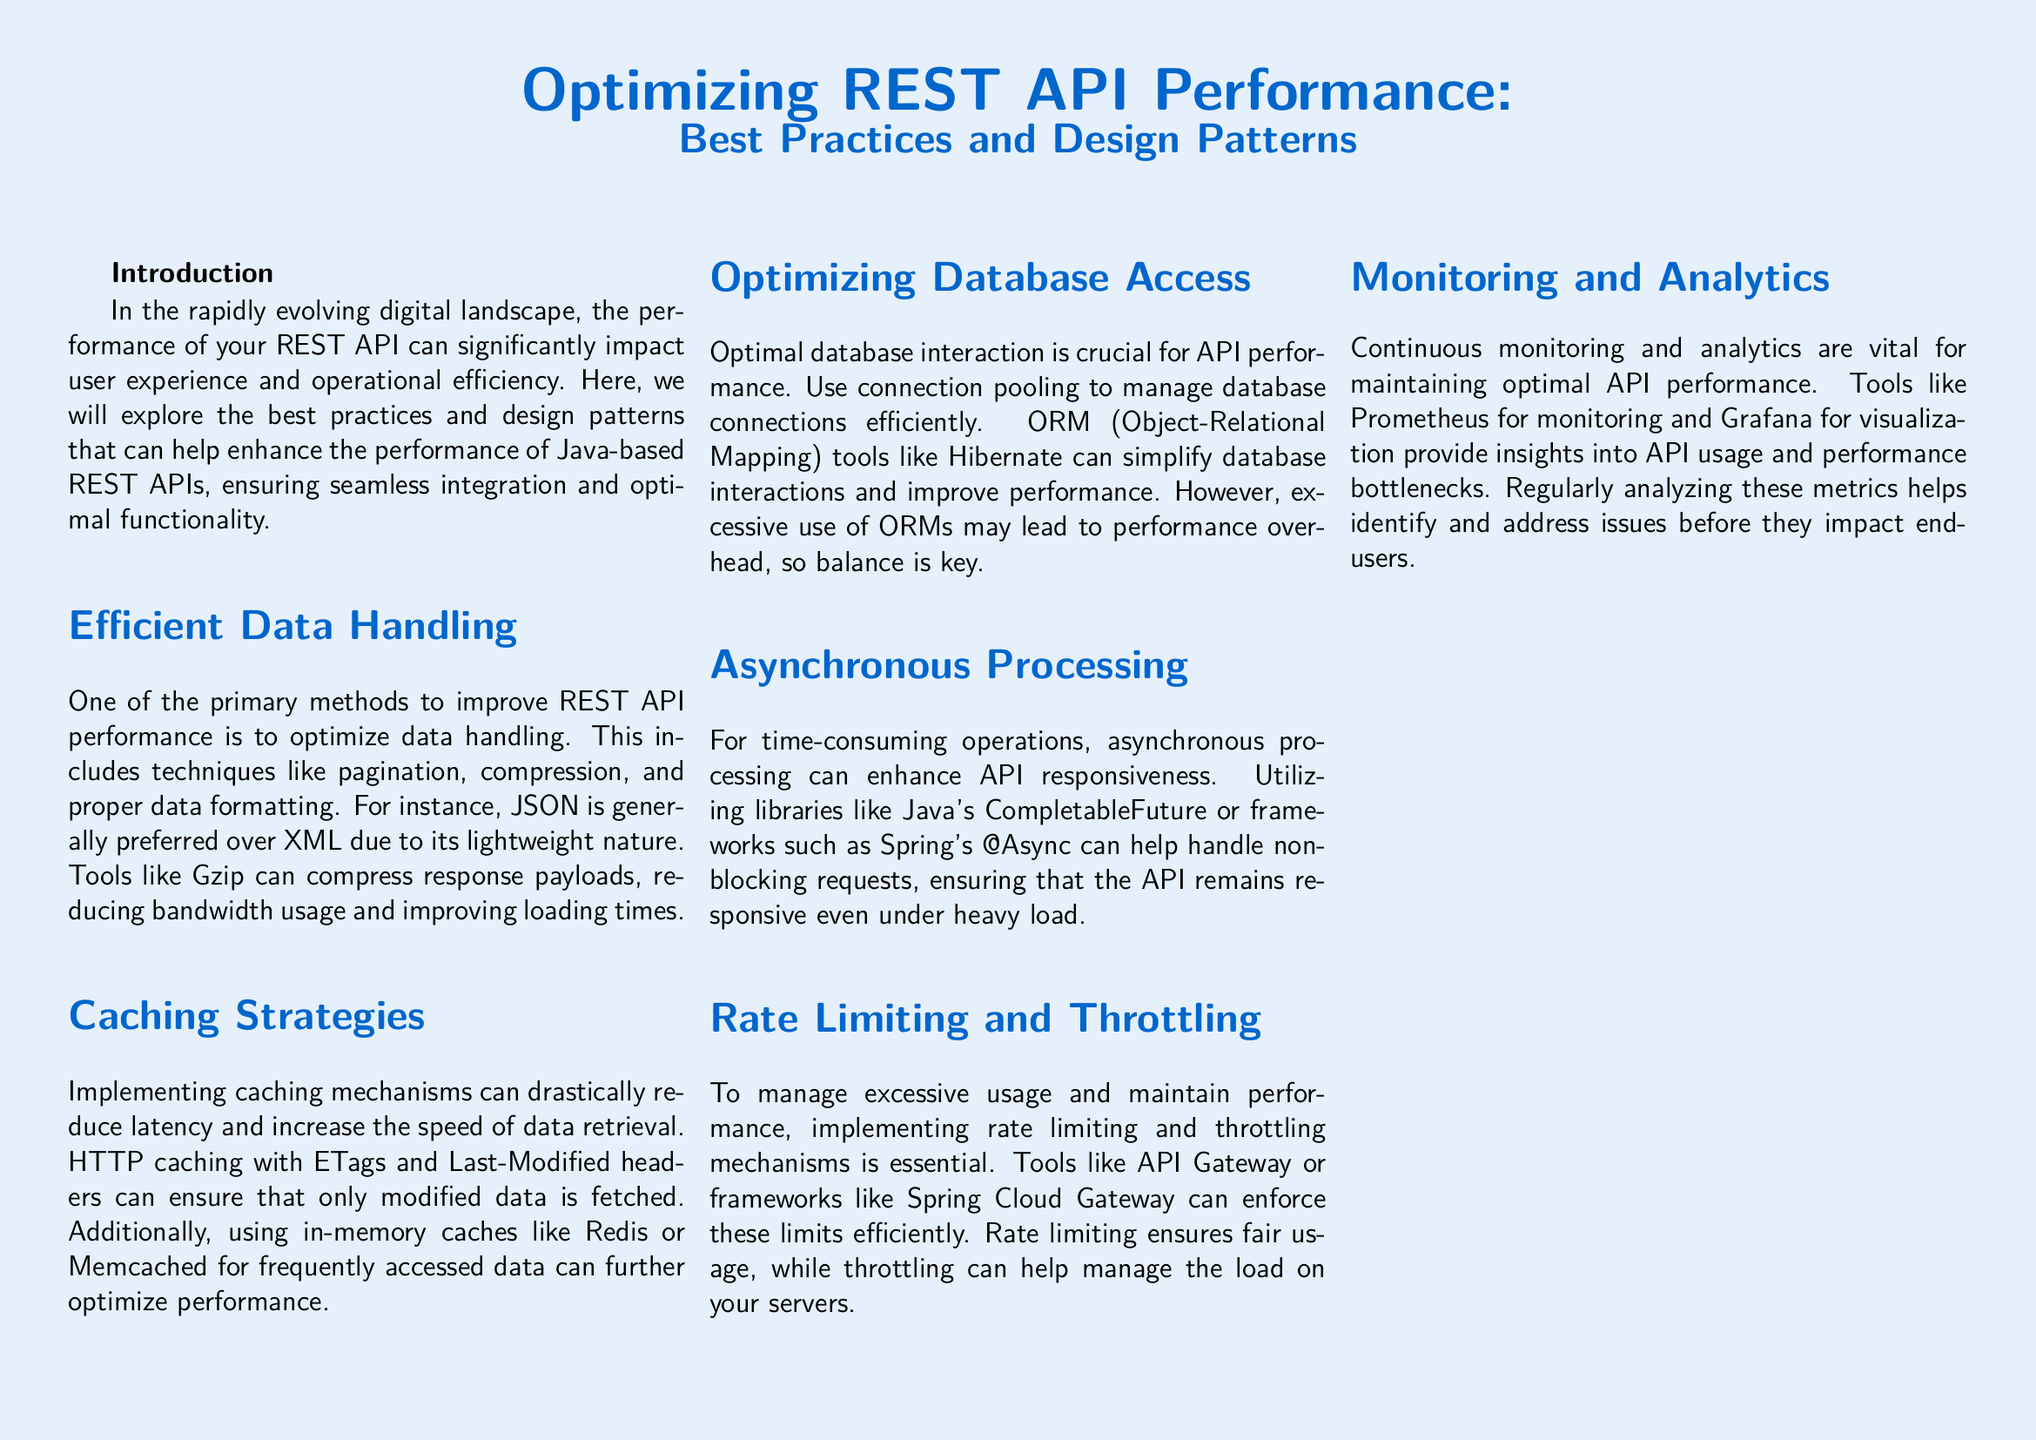What is the main topic of the whitepaper? The main topic of the whitepaper is about improving performance in REST APIs, particularly for Java-based systems.
Answer: Optimizing REST API Performance What should be preferred for data formatting in REST APIs? JSON is preferred because of its lightweight nature compared to XML.
Answer: JSON Which caching tools are mentioned in the document? The document mentions in-memory caches like Redis and Memcached for optimizing performance.
Answer: Redis, Memcached What is a critical method for enhancing API responsiveness for time-consuming operations? Asynchronous processing is highlighted as a necessary enhancement for API responsiveness.
Answer: Asynchronous processing Which monitoring tools are suggested for maintaining optimal API performance? The document suggests using Prometheus for monitoring and Grafana for visualization of API performance.
Answer: Prometheus, Grafana What is a key benefit of implementing rate limiting? Rate limiting ensures fair usage of the API among different users.
Answer: Fair usage What should be done to achieve efficient database access? The document recommends using connection pooling to manage database connections efficiently.
Answer: Connection pooling Which libraries or frameworks are recommended for handling non-blocking requests? The recommended libraries include Java's CompletableFuture and Spring's @Async framework.
Answer: CompletableFuture, @Async What is one aspect that continuous monitoring can help with? Continuous monitoring helps identify and address performance bottlenecks before they affect end-users.
Answer: Performance bottlenecks 